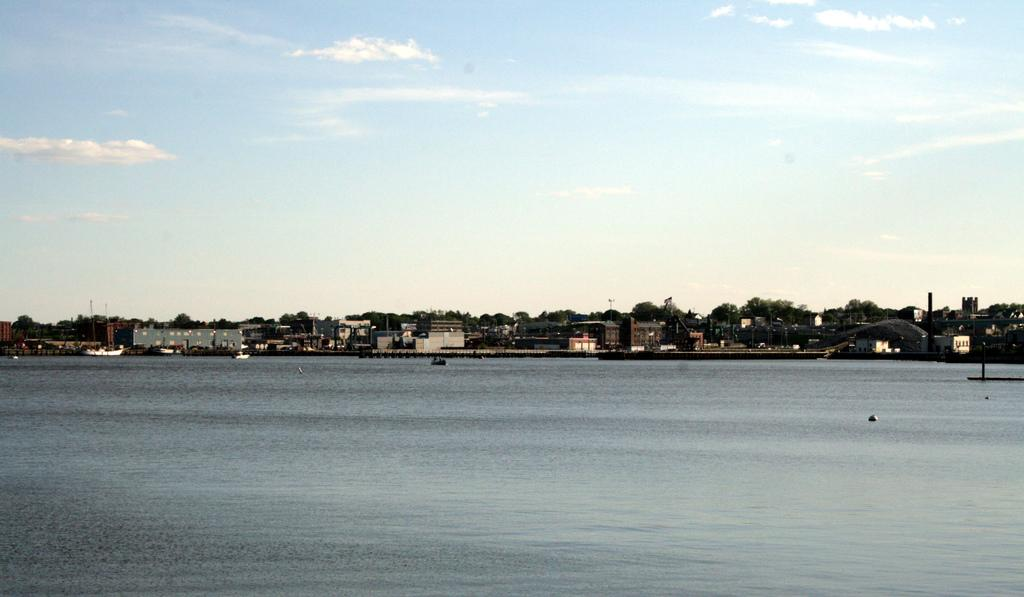What type of water is present in the front of the image? There is river water in the front of the image. What can be seen in the distance behind the river? There are buildings and trees visible in the background of the image. What is visible at the top of the image? The sky is visible at the top of the image. What type of blood can be seen flowing in the river in the image? There is no blood present in the image; it is river water. What star can be seen shining brightly in the sky in the image? There is no star visible in the image; only the sky is visible. 